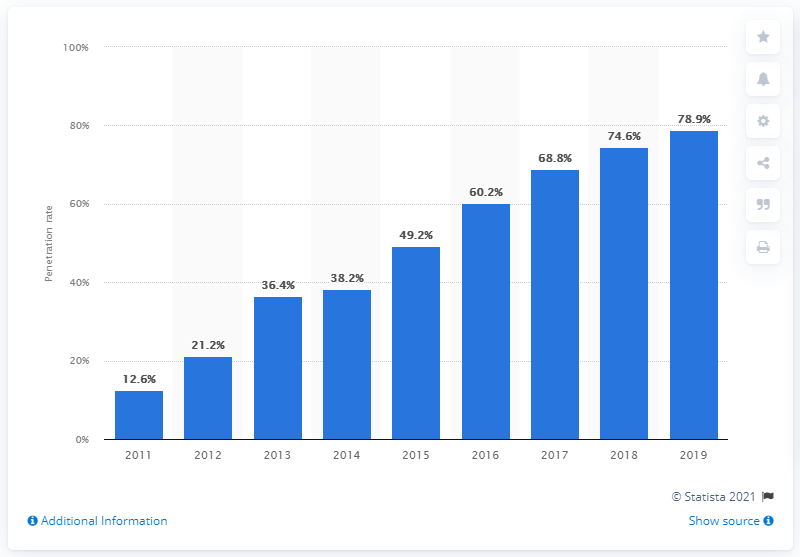Point out several critical features in this image. In 2011, the percentage of internet accounts in the Dominican Republic was 12.6%. 